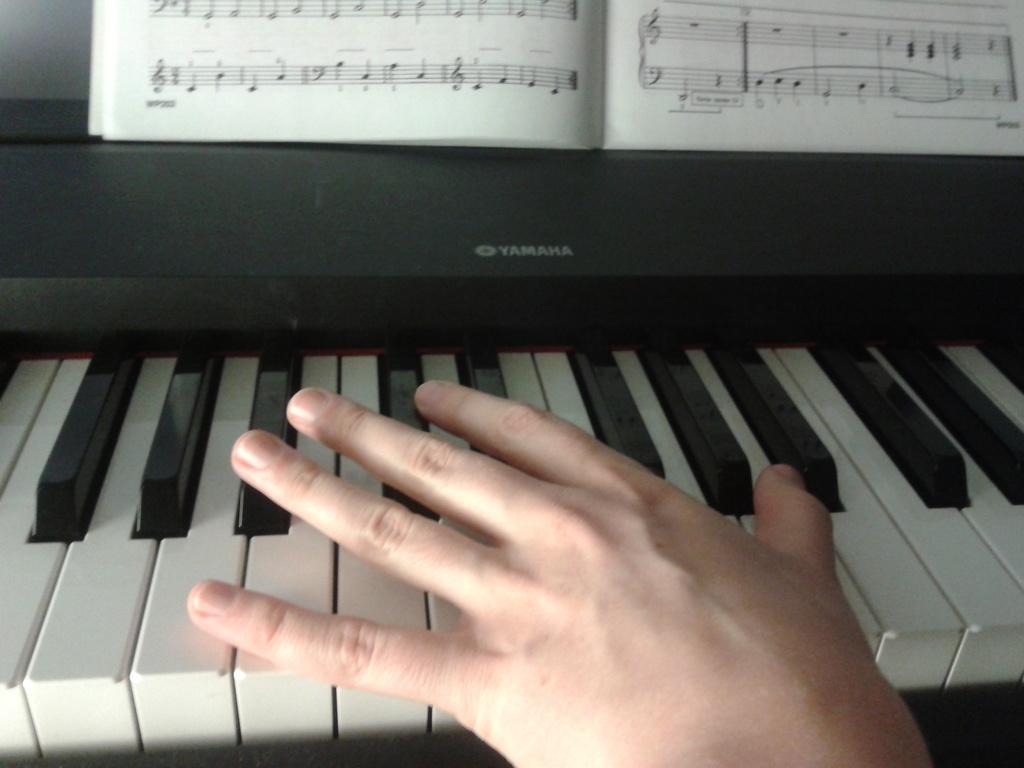Can you describe this image briefly? In this image I see a person's hand on the piano and there is a book over here. 